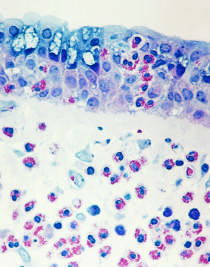s typical tuberculous granuloma showing an area of central necrosis characterized by an inflammatory infiltrate rich in eosinophils, neutrophils, and t cells?
Answer the question using a single word or phrase. No 